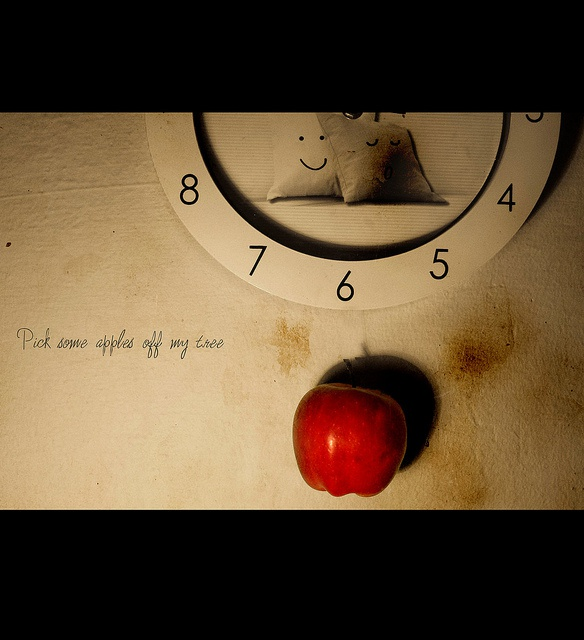Describe the objects in this image and their specific colors. I can see clock in black, tan, and olive tones and apple in black, maroon, and brown tones in this image. 